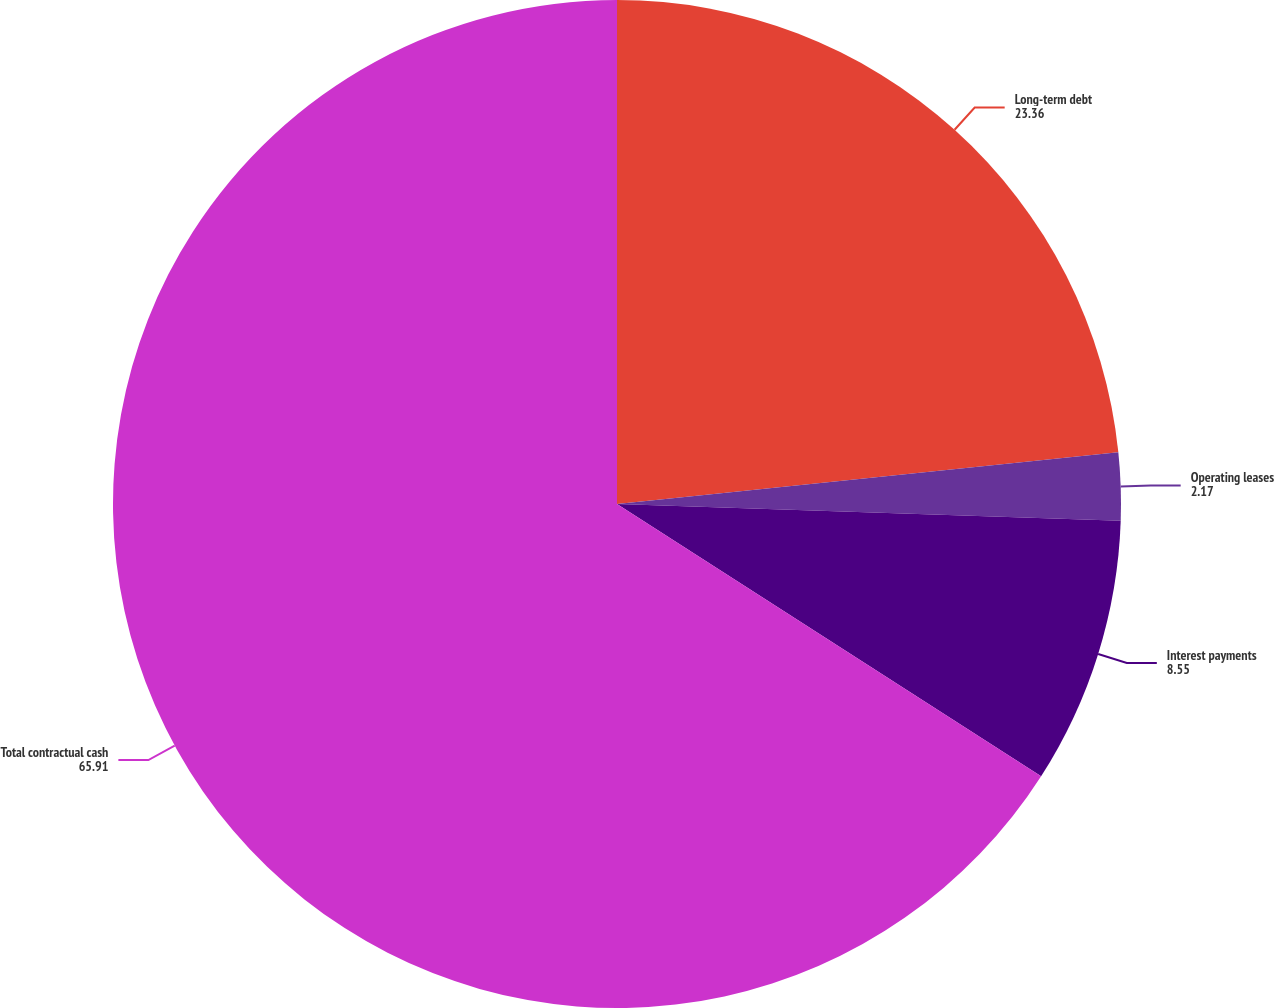Convert chart. <chart><loc_0><loc_0><loc_500><loc_500><pie_chart><fcel>Long-term debt<fcel>Operating leases<fcel>Interest payments<fcel>Total contractual cash<nl><fcel>23.36%<fcel>2.17%<fcel>8.55%<fcel>65.91%<nl></chart> 